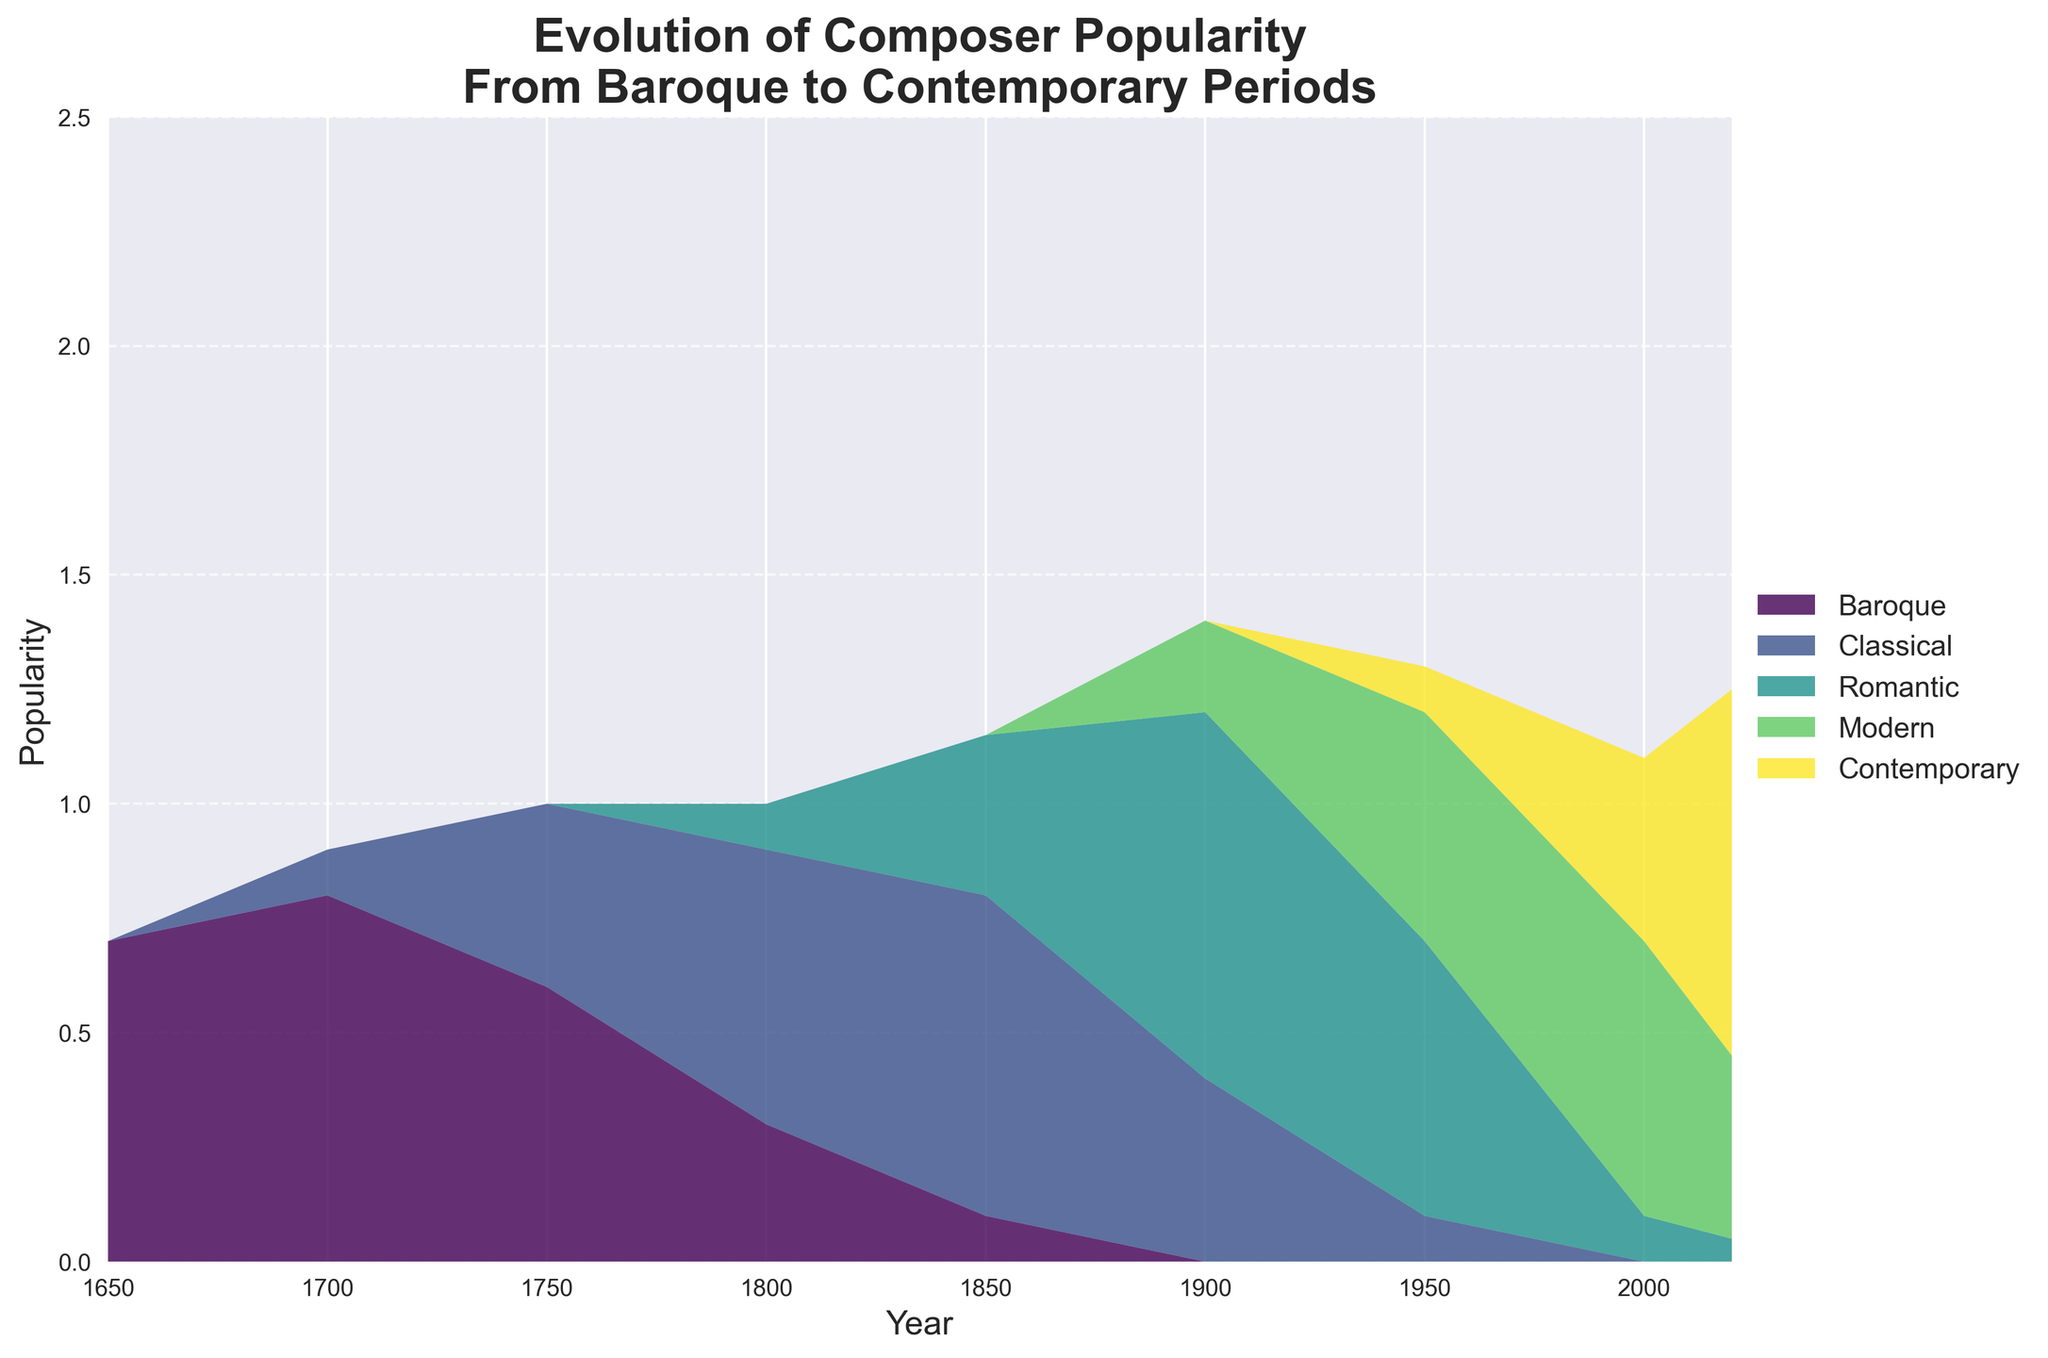Which era shows the highest composer popularity around the year 1800? Look at the height of each stream section corresponding to the year 1800. The Classical period has the highest value.
Answer: Classical What is the general trend in the popularity of Baroque composers from 1650 to 2020? Observe the Baroque stream from 1650 to 2020. It starts high around 0.7 in 1650 and decreases to 0 by 1900, remaining at 0 thereafter.
Answer: Decreasing How does the popularity of Romantic composers in 1900 compare to that in 2000? Compare the height of the Romantic segment at both years. In 1900, it is about 0.8, while in 2000 it is around 0.1.
Answer: Higher in 1900 Between the years 1700 and 1800, which era saw the greatest increase in popularity? Calculate the change for each era: Baroque decreases by about 0.5 (0.8 to 0.3), Classical increases by about 0.5 (0.1 to 0.6), Romantic increases by 0.1 (0 to 0.1). Therefore, Classical has the greatest increase.
Answer: Classical How does the popularity of Modern composers in 2020 compare to Contemporary composers in 2020? Compare the height of the Modern and Contemporary segments in 2020; Modern is around 0.4, and Contemporary is around 0.8.
Answer: Contemporary is higher What is the approximate sum of the popularity of Baroque, Classical, and Romantic composers in 1750? Add the values for Baroque (0.6), Classical (0.4), and Romantic (0) around 1750, which equals 1.0.
Answer: 1.0 What is a notable trend observed for Contemporary composers from 2000 to 2020? Look at the Contemporary stream from 2000 to 2020. It shows a noticeable increase from about 0.4 to 0.8.
Answer: Increasing How does the sum of the popularity of all eras change from 1650 to 2020? The sum of all era popularity remains constant across all years because the y-axis reaches the same total height consistently at around 2.5.
Answer: Constant What is the general shape of the Modern era's popularity curve from 1800 to 2020? Observe the Modern stream from 1800 onwards. It gradually increases, peaking around 1950, and then decreases slightly by 2020.
Answer: Bell-shaped In which era does the Classical period show the first significant appearance? Look for the first notable rise in the Classical segment. This happens around 1700.
Answer: Around 1700 